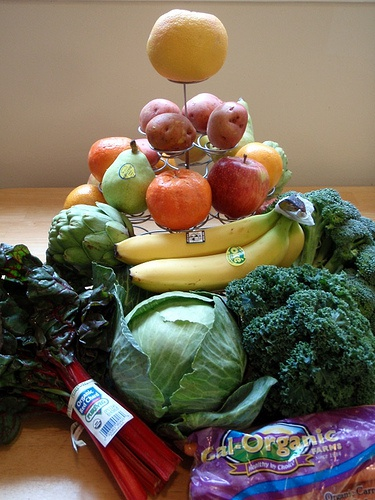Describe the objects in this image and their specific colors. I can see broccoli in gray, black, teal, and darkgreen tones, dining table in gray, brown, maroon, and lightgray tones, banana in gray, olive, tan, and khaki tones, orange in gray, olive, white, orange, and tan tones, and orange in gray, brown, red, and salmon tones in this image. 